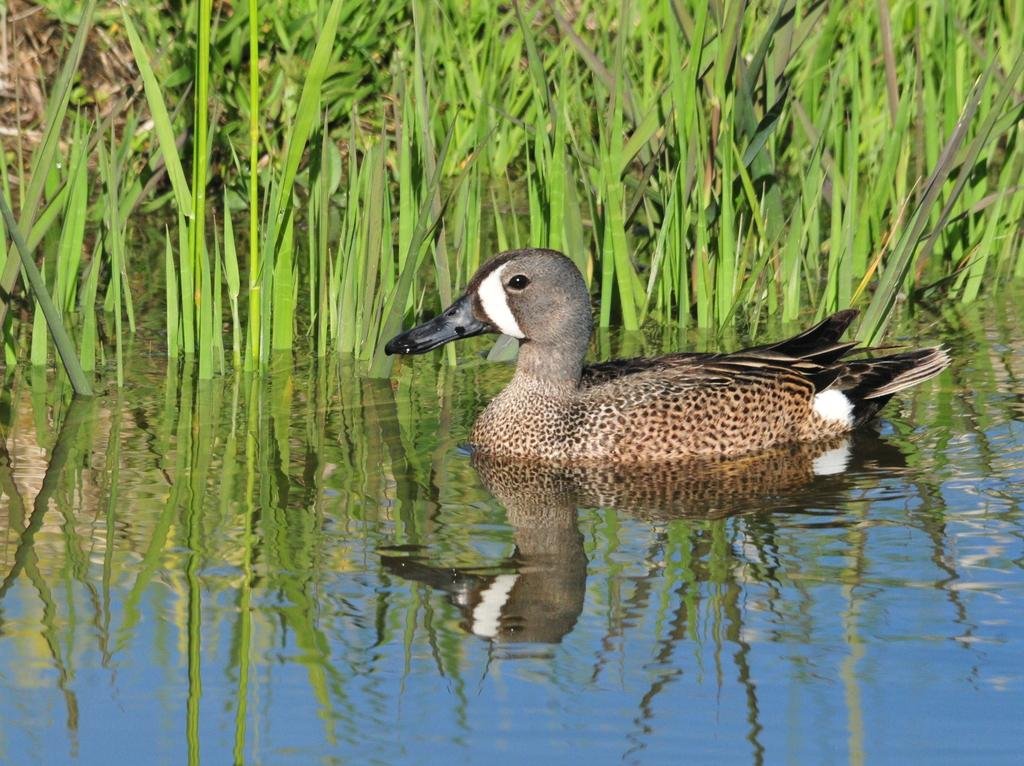What animal is in the water in the image? There is a duck in the water in the image. What can be seen behind the duck? There are plants behind the duck. What is visible on the water's surface? The reflection of the sky is visible on the water. What time of day does the duck burst into the hour in the image? There is no duck bursting into an hour in the image, as this is not a concept related to the image's content. 